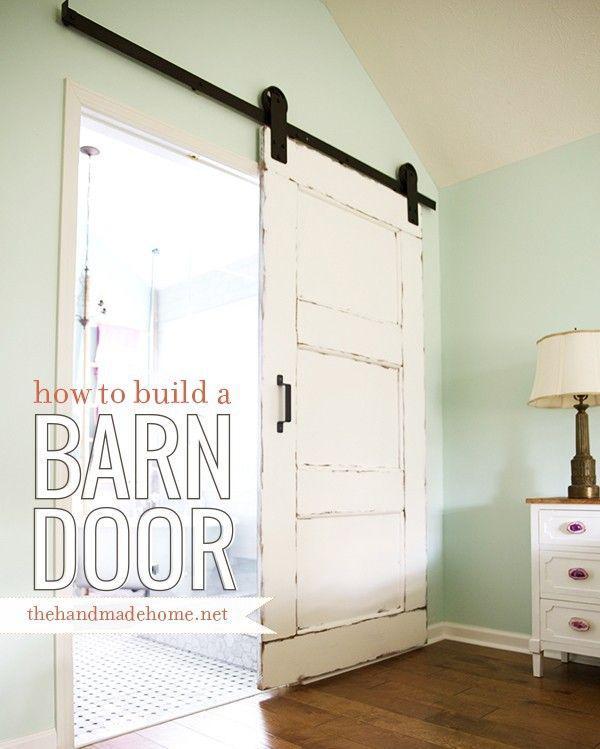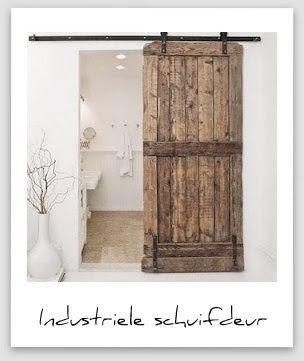The first image is the image on the left, the second image is the image on the right. Examine the images to the left and right. Is the description "There is a lamp in one of the images." accurate? Answer yes or no. Yes. 